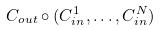Convert formula to latex. <formula><loc_0><loc_0><loc_500><loc_500>C _ { o u t } \circ ( C _ { i n } ^ { 1 } , \dots , C _ { i n } ^ { N } )</formula> 